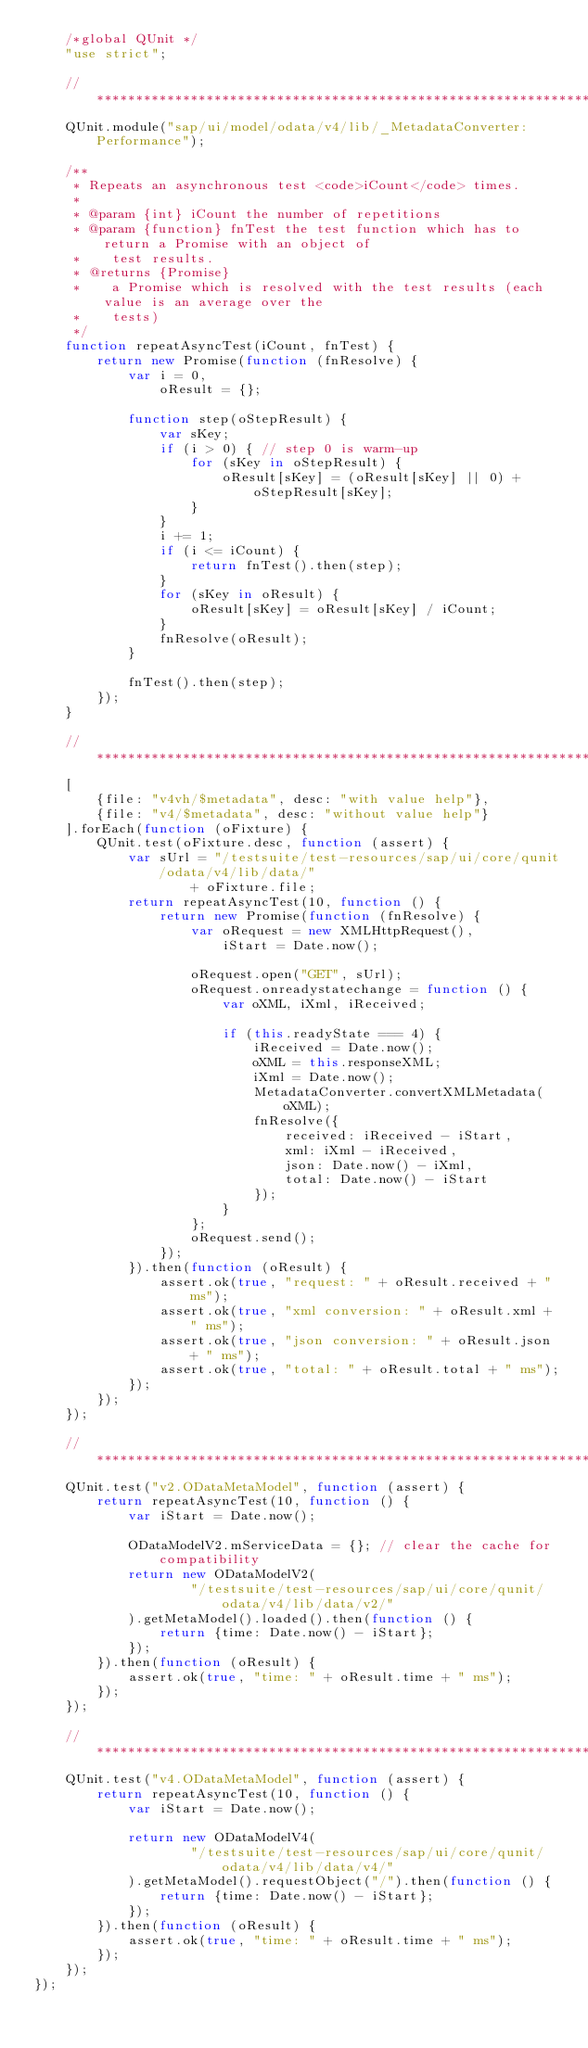<code> <loc_0><loc_0><loc_500><loc_500><_JavaScript_>	/*global QUnit */
	"use strict";

	//*********************************************************************************************
	QUnit.module("sap/ui/model/odata/v4/lib/_MetadataConverter: Performance");

	/**
	 * Repeats an asynchronous test <code>iCount</code> times.
	 *
	 * @param {int} iCount the number of repetitions
	 * @param {function} fnTest the test function which has to return a Promise with an object of
	 *    test results.
	 * @returns {Promise}
	 *    a Promise which is resolved with the test results (each value is an average over the
	 *    tests)
	 */
	function repeatAsyncTest(iCount, fnTest) {
		return new Promise(function (fnResolve) {
			var i = 0,
				oResult = {};

			function step(oStepResult) {
				var sKey;
				if (i > 0) { // step 0 is warm-up
					for (sKey in oStepResult) {
						oResult[sKey] = (oResult[sKey] || 0) + oStepResult[sKey];
					}
				}
				i += 1;
				if (i <= iCount) {
					return fnTest().then(step);
				}
				for (sKey in oResult) {
					oResult[sKey] = oResult[sKey] / iCount;
				}
				fnResolve(oResult);
			}

			fnTest().then(step);
		});
	}

	//*********************************************************************************************
	[
		{file: "v4vh/$metadata", desc: "with value help"},
		{file: "v4/$metadata", desc: "without value help"}
	].forEach(function (oFixture) {
		QUnit.test(oFixture.desc, function (assert) {
			var sUrl = "/testsuite/test-resources/sap/ui/core/qunit/odata/v4/lib/data/"
					+ oFixture.file;
			return repeatAsyncTest(10, function () {
				return new Promise(function (fnResolve) {
					var oRequest = new XMLHttpRequest(),
						iStart = Date.now();

					oRequest.open("GET", sUrl);
					oRequest.onreadystatechange = function () {
						var oXML, iXml, iReceived;

						if (this.readyState === 4) {
							iReceived = Date.now();
							oXML = this.responseXML;
							iXml = Date.now();
							MetadataConverter.convertXMLMetadata(oXML);
							fnResolve({
								received: iReceived - iStart,
								xml: iXml - iReceived,
								json: Date.now() - iXml,
								total: Date.now() - iStart
							});
						}
					};
					oRequest.send();
				});
			}).then(function (oResult) {
				assert.ok(true, "request: " + oResult.received + " ms");
				assert.ok(true, "xml conversion: " + oResult.xml + " ms");
				assert.ok(true, "json conversion: " + oResult.json + " ms");
				assert.ok(true, "total: " + oResult.total + " ms");
			});
		});
	});

	//*********************************************************************************************
	QUnit.test("v2.ODataMetaModel", function (assert) {
		return repeatAsyncTest(10, function () {
			var iStart = Date.now();

			ODataModelV2.mServiceData = {}; // clear the cache for compatibility
			return new ODataModelV2(
					"/testsuite/test-resources/sap/ui/core/qunit/odata/v4/lib/data/v2/"
			).getMetaModel().loaded().then(function () {
				return {time: Date.now() - iStart};
			});
		}).then(function (oResult) {
			assert.ok(true, "time: " + oResult.time + " ms");
		});
	});

	//*********************************************************************************************
	QUnit.test("v4.ODataMetaModel", function (assert) {
		return repeatAsyncTest(10, function () {
			var iStart = Date.now();

			return new ODataModelV4(
					"/testsuite/test-resources/sap/ui/core/qunit/odata/v4/lib/data/v4/"
			).getMetaModel().requestObject("/").then(function () {
				return {time: Date.now() - iStart};
			});
		}).then(function (oResult) {
			assert.ok(true, "time: " + oResult.time + " ms");
		});
	});
});
</code> 